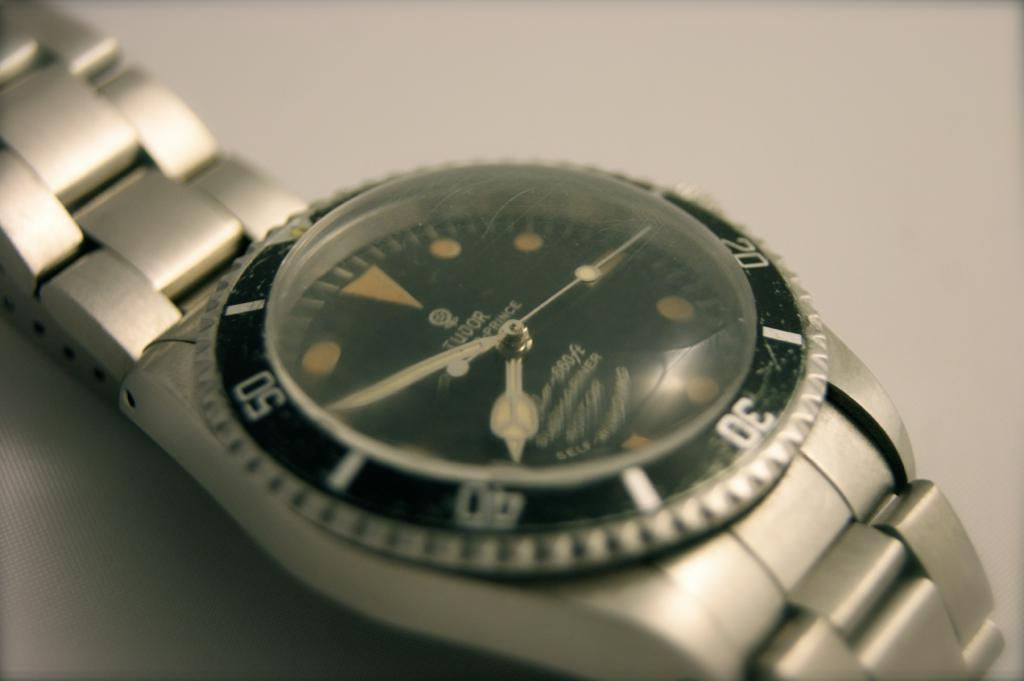<image>
Share a concise interpretation of the image provided. A Tudor brand watch has a metal wristband. 